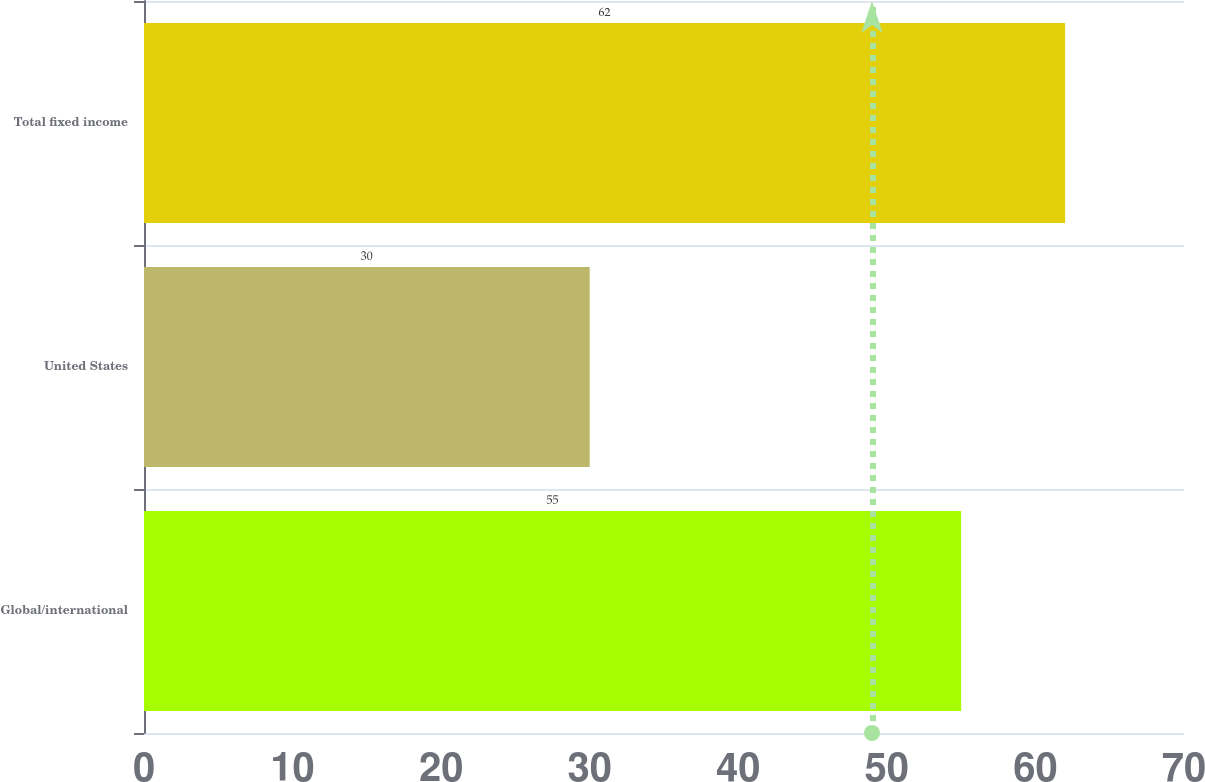<chart> <loc_0><loc_0><loc_500><loc_500><bar_chart><fcel>Global/international<fcel>United States<fcel>Total fixed income<nl><fcel>55<fcel>30<fcel>62<nl></chart> 